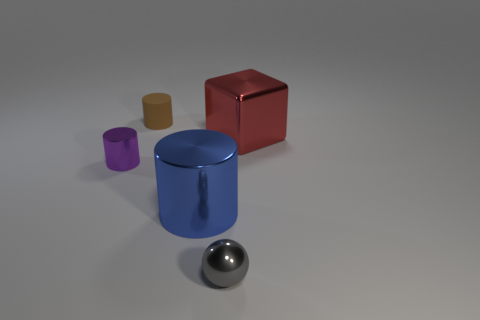Can you describe the colors and shapes of the objects present in the image? Certainly! There's a variety of objects with different colors and shapes. A red cube, a blue cylinder, a purple smaller cylinder, and a golden short cylinder, along with a shiny sphere that reflects the environment. All objects are set on a neutral gray surface. 